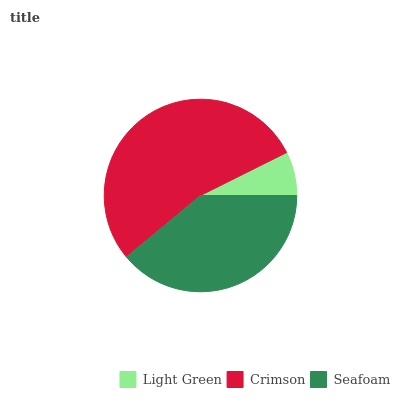Is Light Green the minimum?
Answer yes or no. Yes. Is Crimson the maximum?
Answer yes or no. Yes. Is Seafoam the minimum?
Answer yes or no. No. Is Seafoam the maximum?
Answer yes or no. No. Is Crimson greater than Seafoam?
Answer yes or no. Yes. Is Seafoam less than Crimson?
Answer yes or no. Yes. Is Seafoam greater than Crimson?
Answer yes or no. No. Is Crimson less than Seafoam?
Answer yes or no. No. Is Seafoam the high median?
Answer yes or no. Yes. Is Seafoam the low median?
Answer yes or no. Yes. Is Crimson the high median?
Answer yes or no. No. Is Crimson the low median?
Answer yes or no. No. 